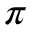<formula> <loc_0><loc_0><loc_500><loc_500>\pi</formula> 